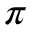<formula> <loc_0><loc_0><loc_500><loc_500>\pi</formula> 